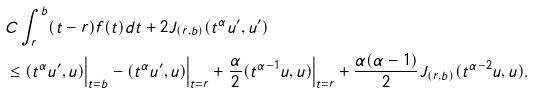Convert formula to latex. <formula><loc_0><loc_0><loc_500><loc_500>& C \int _ { r } ^ { b } ( t - r ) f ( t ) d t + 2 J _ { ( r , b ) } ( t ^ { \alpha } u ^ { \prime } , u ^ { \prime } ) \\ & \leq ( t ^ { \alpha } u ^ { \prime } , u ) \Big | _ { t = b } - ( t ^ { \alpha } u ^ { \prime } , u ) \Big | _ { t = r } + \frac { \alpha } { 2 } ( t ^ { \alpha - 1 } u , u ) \Big | _ { t = r } + \frac { \alpha ( \alpha - 1 ) } { 2 } J _ { ( r , b ) } ( t ^ { \alpha - 2 } u , u ) .</formula> 